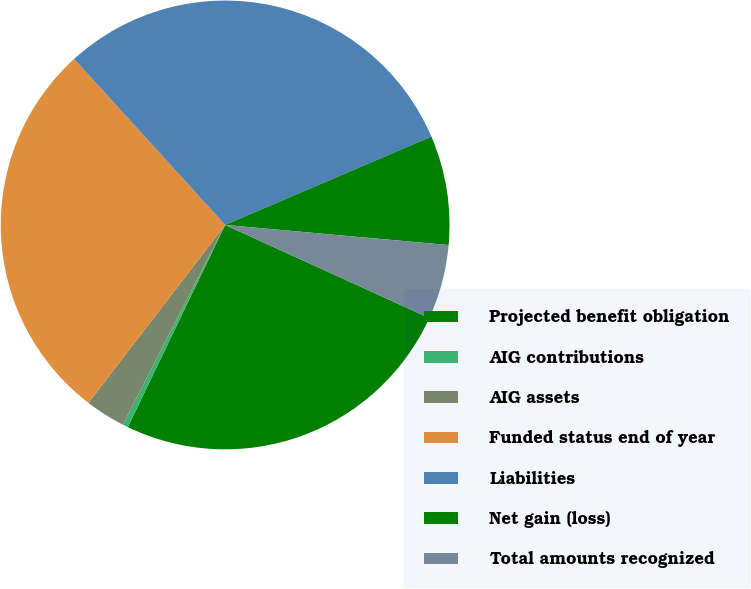<chart> <loc_0><loc_0><loc_500><loc_500><pie_chart><fcel>Projected benefit obligation<fcel>AIG contributions<fcel>AIG assets<fcel>Funded status end of year<fcel>Liabilities<fcel>Net gain (loss)<fcel>Total amounts recognized<nl><fcel>25.33%<fcel>0.4%<fcel>2.89%<fcel>27.82%<fcel>30.31%<fcel>7.87%<fcel>5.38%<nl></chart> 